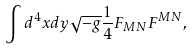Convert formula to latex. <formula><loc_0><loc_0><loc_500><loc_500>\int d ^ { 4 } x d y \sqrt { - g } \frac { 1 } { 4 } F _ { M N } F ^ { M N } ,</formula> 